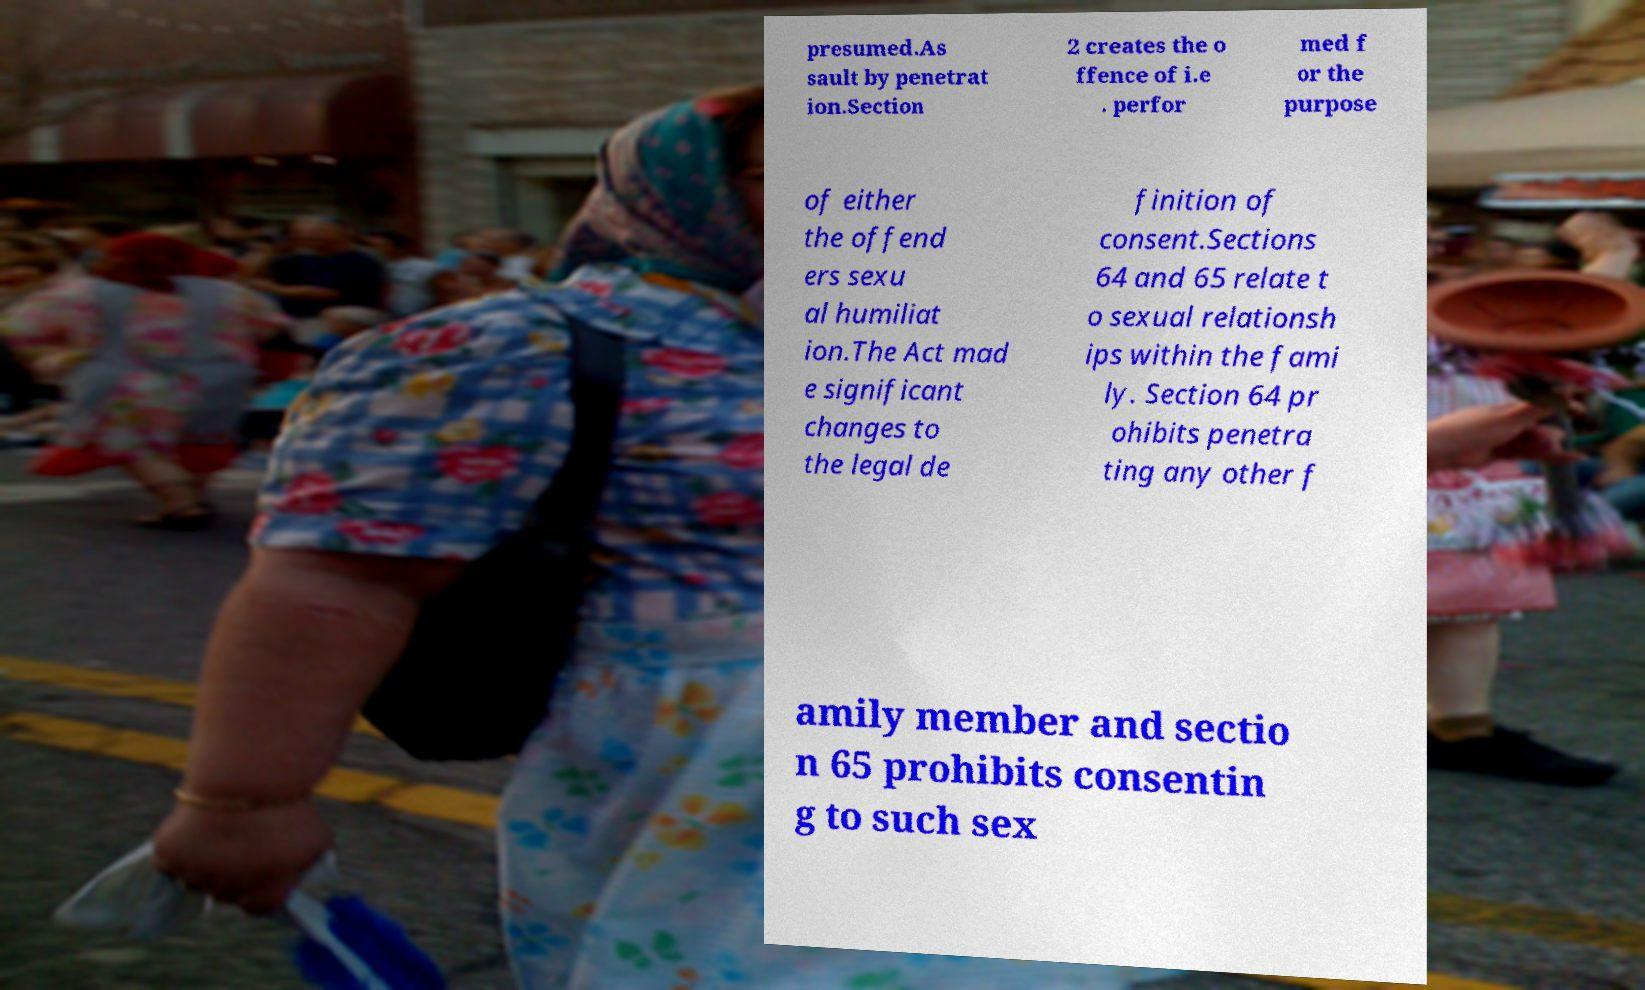Can you accurately transcribe the text from the provided image for me? presumed.As sault by penetrat ion.Section 2 creates the o ffence of i.e . perfor med f or the purpose of either the offend ers sexu al humiliat ion.The Act mad e significant changes to the legal de finition of consent.Sections 64 and 65 relate t o sexual relationsh ips within the fami ly. Section 64 pr ohibits penetra ting any other f amily member and sectio n 65 prohibits consentin g to such sex 